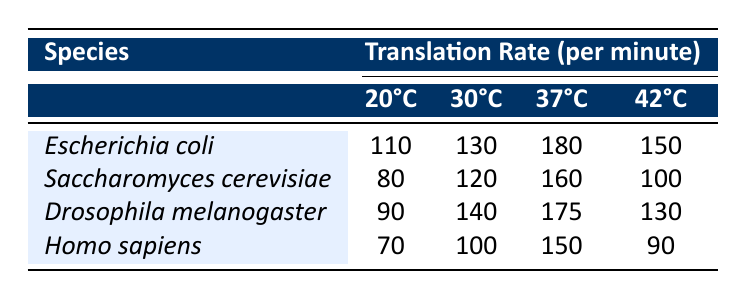What is the translation rate for Escherichia coli at 37°C? Escherichia coli has a translation rate of 180 per minute at 37°C, as indicated in the corresponding row and column of the table.
Answer: 180 Which species has the highest translation rate at 30°C? At 30°C, the translation rates for each species are as follows: Escherichia coli 130, Saccharomyces cerevisiae 120, Drosophila melanogaster 140, and Homo sapiens 100. The highest is 140 for Drosophila melanogaster.
Answer: Drosophila melanogaster What is the average translation rate for Homo sapiens across all temperatures? The translation rates for Homo sapiens are 70 (20°C), 100 (30°C), 150 (37°C), and 90 (42°C). The sum is 70 + 100 + 150 + 90 = 410. There are 4 data points, so the average is 410 / 4 = 102.5.
Answer: 102.5 Does the translation rate for Saccharomyces cerevisiae decrease at 42°C compared to 37°C? At 37°C, the translation rate for Saccharomyces cerevisiae is 160 and at 42°C it is 100. Since 100 is less than 160, it does decrease at 42°C compared to 37°C.
Answer: Yes What is the difference in translation rates between Drosophila melanogaster at 30°C and Homo sapiens at 37°C? Drosophila melanogaster has a translation rate of 140 at 30°C, while Homo sapiens has a rate of 150 at 37°C. The difference is 150 - 140 = 10.
Answer: 10 